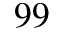Convert formula to latex. <formula><loc_0><loc_0><loc_500><loc_500>^ { 9 9 }</formula> 